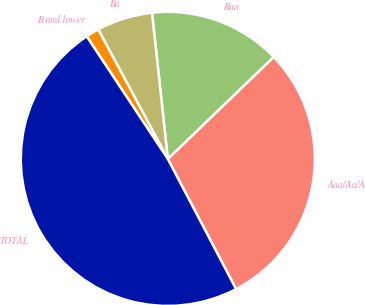Convert chart to OTSL. <chart><loc_0><loc_0><loc_500><loc_500><pie_chart><fcel>Aaa/Aa/A<fcel>Baa<fcel>Ba<fcel>B and lower<fcel>TOTAL<nl><fcel>29.51%<fcel>14.51%<fcel>6.14%<fcel>1.45%<fcel>48.38%<nl></chart> 